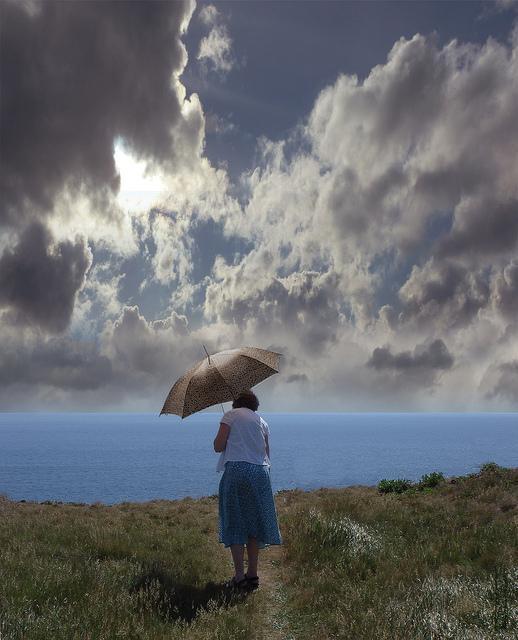How many people are sitting under the umbrella?
Give a very brief answer. 1. How many people are shown?
Give a very brief answer. 1. How many umbrellas are there?
Give a very brief answer. 1. 